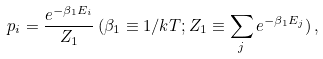Convert formula to latex. <formula><loc_0><loc_0><loc_500><loc_500>p _ { i } = \frac { e ^ { - \beta _ { 1 } E _ { i } } } { Z _ { 1 } } \, ( \beta _ { 1 } \equiv 1 / k T ; Z _ { 1 } \equiv \sum _ { j } e ^ { - \beta _ { 1 } E _ { j } } ) \, ,</formula> 